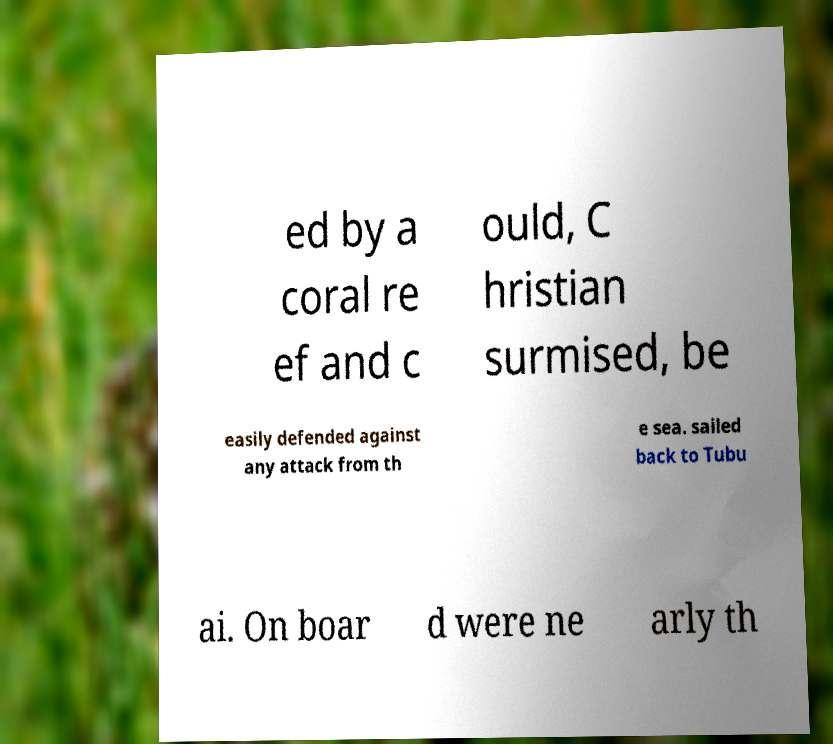For documentation purposes, I need the text within this image transcribed. Could you provide that? ed by a coral re ef and c ould, C hristian surmised, be easily defended against any attack from th e sea. sailed back to Tubu ai. On boar d were ne arly th 